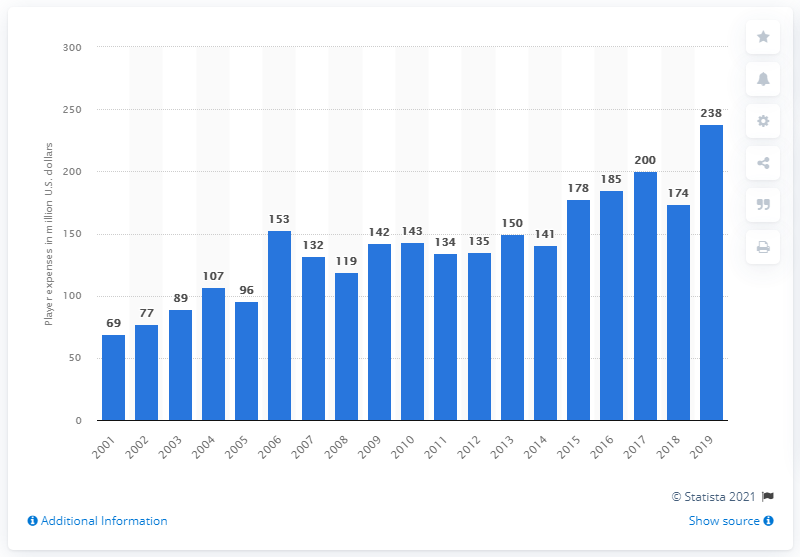Highlight a few significant elements in this photo. The player expenses of the Indianapolis Colts in the 2019 season were approximately 238. 